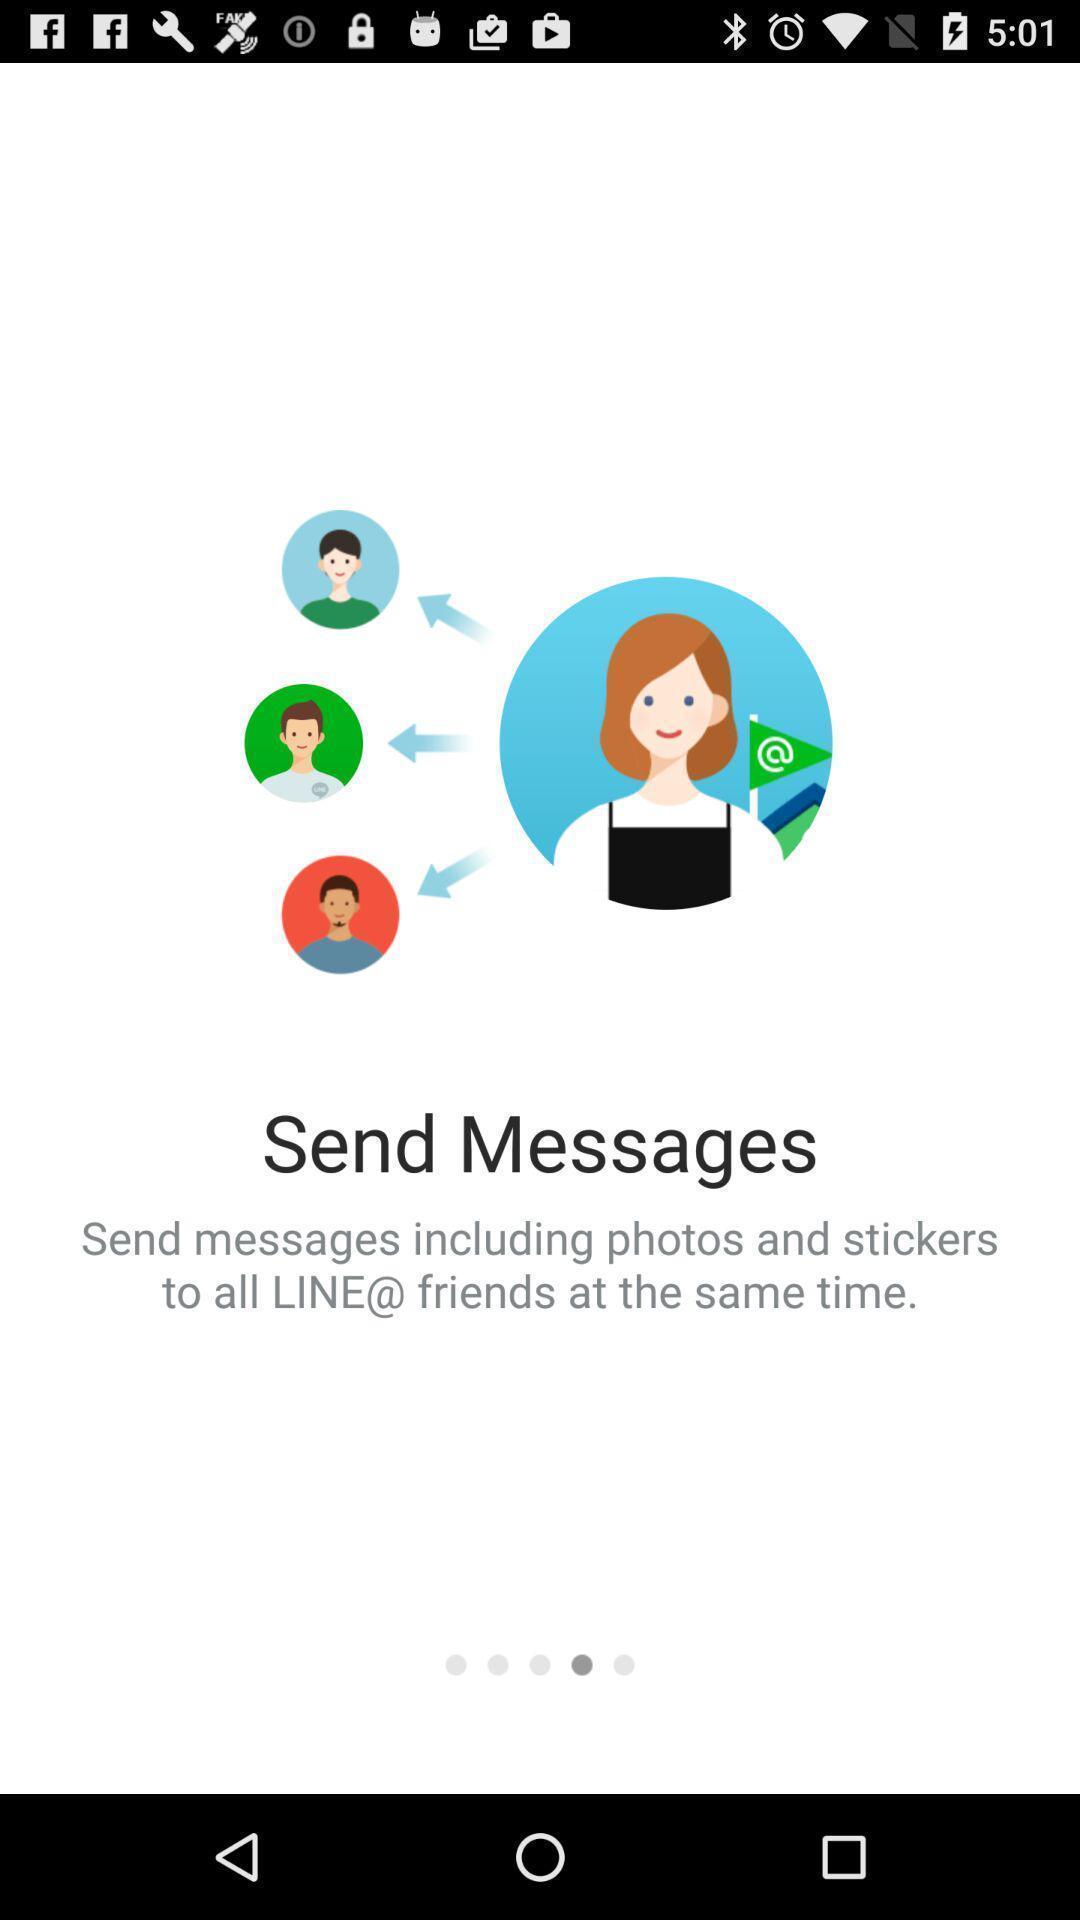Describe the visual elements of this screenshot. Window displaying a messaging app. 